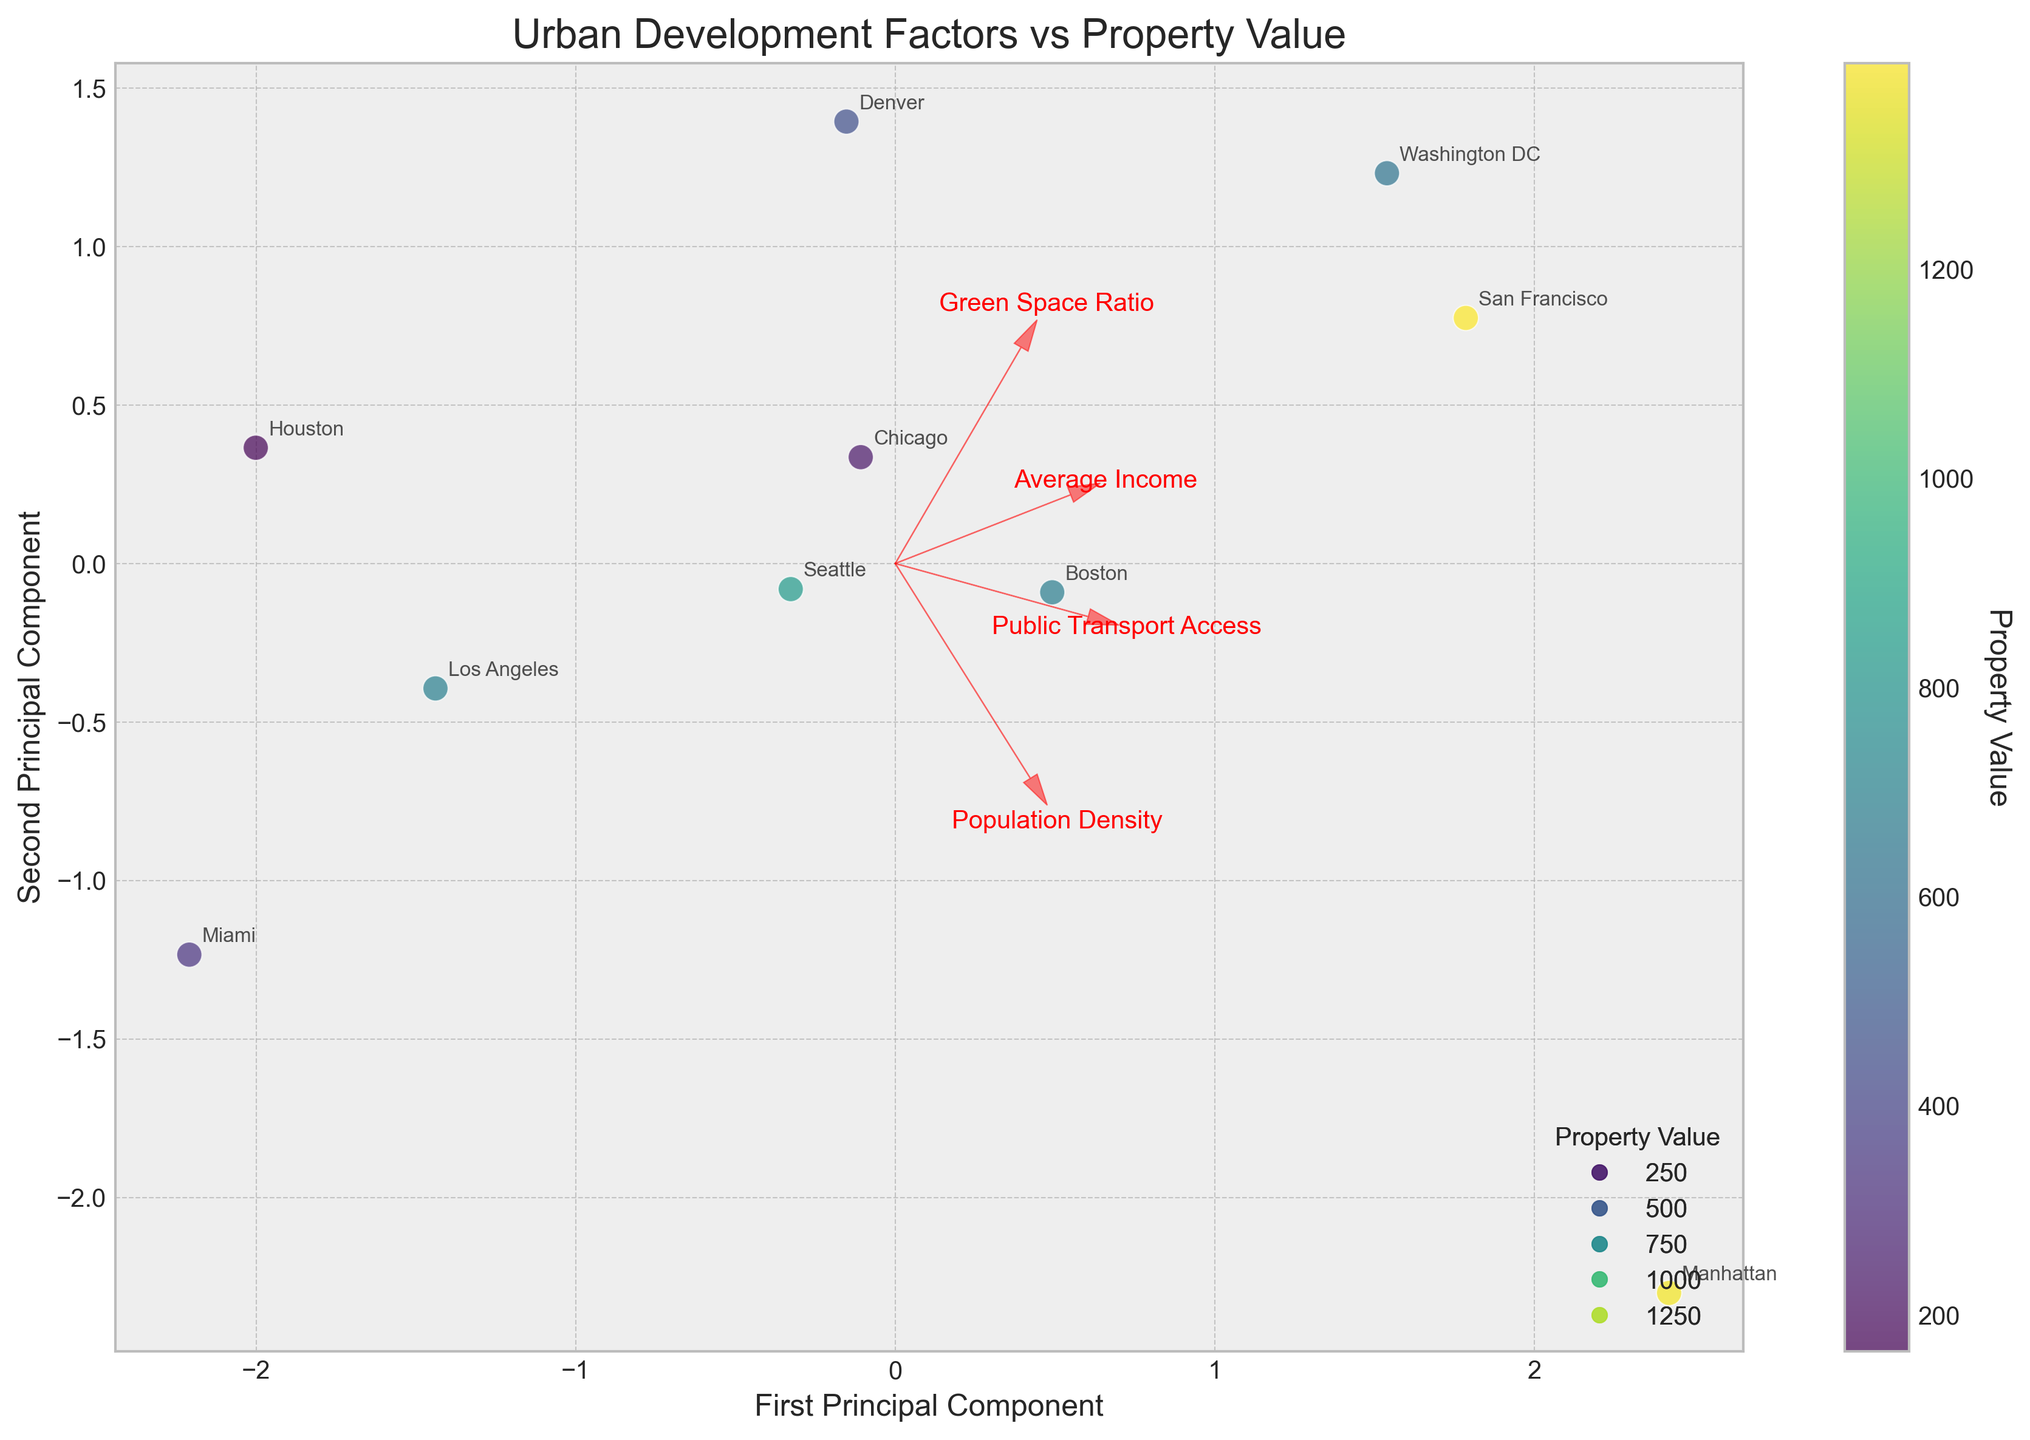What's the title of the plot? The title of the plot is displayed at the top of the figure, which summarizes the theme being visualized.
Answer: Urban Development Factors vs Property Value How many data points are represented in the biplot? The biplot includes every labeled data point representing a location. By counting these labels, we determine the total number of data points.
Answer: 10 Which location has the highest property value and where is it located in the plot? By looking at the color bar and identifying the data point with the darkest color, we can determine which location has the highest property value. From the plot, we then find the label corresponding to this location.
Answer: San Francisco Which two locations appear the most similar in terms of urban development factors? By identifying data points that are closest together in the biplot, we can infer that these locations are the most similar in terms of the urban development factors plotted.
Answer: Boston and Washington DC How does 'Public Transport Access' correlate with the first principal component? Locate the vector for 'Public Transport Access' and see its direction and length with respect to the axis labeled 'First Principal Component'. A positive direction with a longer vector indicates a stronger positive correlation.
Answer: Positively Between Los Angeles and Chicago, which has better 'Green Space Ratio' according to the loadings? By observing the direction and magnitude of the 'Green Space Ratio' vector, we can see which data point projects more along this vector. The data point that is closer to the direction of the vector for 'Green Space Ratio' has better values for that factor.
Answer: Chicago What is the overall trend in 'Average Income' shown by the vectors in relation to property values? Examine the vector for 'Average Income' and see its direction relative to the color gradient (property values). If the vector aligns more towards locations with higher value colors, it suggests that higher average incomes are associated with higher property values.
Answer: Higher average income generally correlates with higher property value Which location has the lowest 'Population Density' and how is this visualized in the biplot? Identify the vector representing 'Population Density' and see which location lies furthest in the opposite direction. Confirm it by checking the annotations.
Answer: Houston 